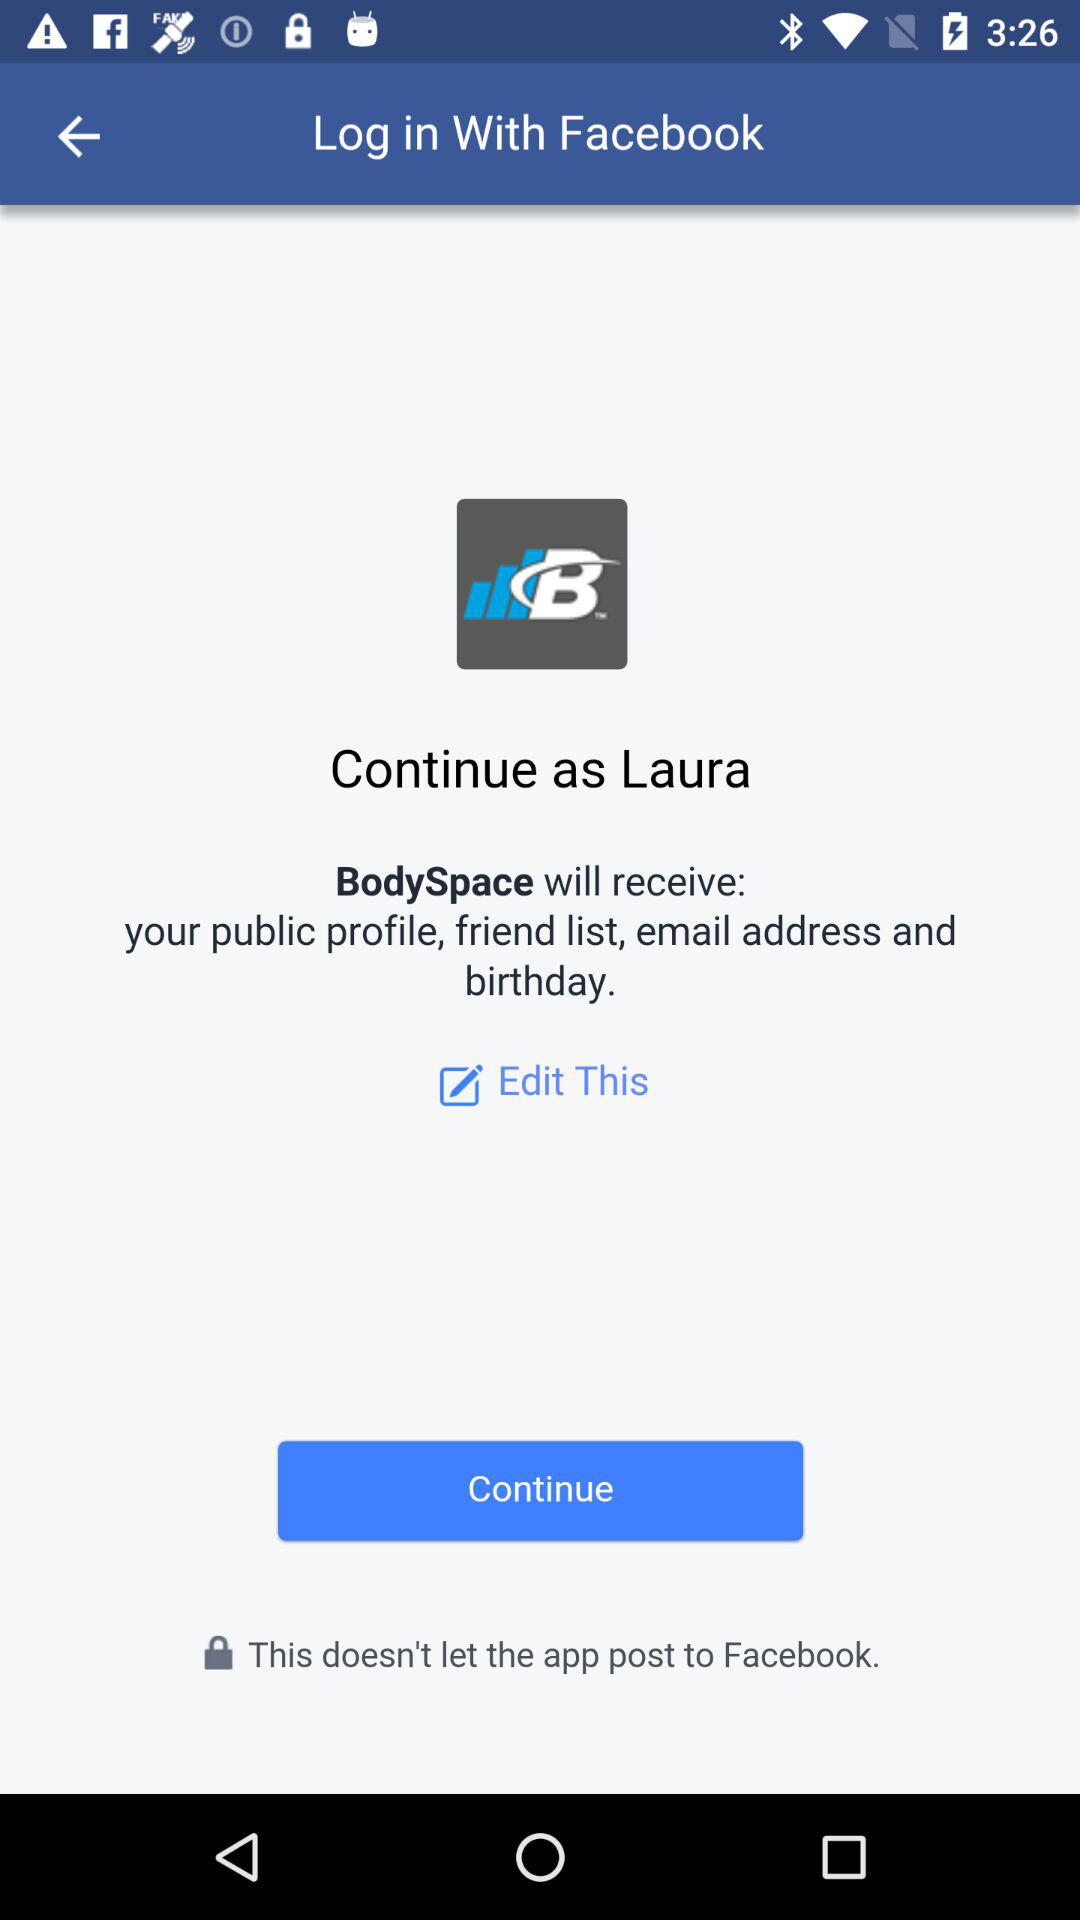What application will receive the public profile, friend list, email address and birthday? The application that will receive the public profile, friend list, email address and birthday is "BodySpace". 